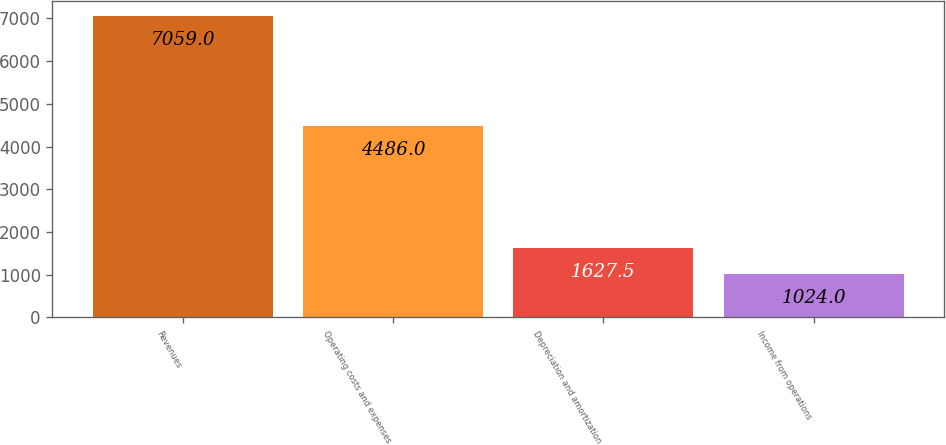Convert chart. <chart><loc_0><loc_0><loc_500><loc_500><bar_chart><fcel>Revenues<fcel>Operating costs and expenses<fcel>Depreciation and amortization<fcel>Income from operations<nl><fcel>7059<fcel>4486<fcel>1627.5<fcel>1024<nl></chart> 